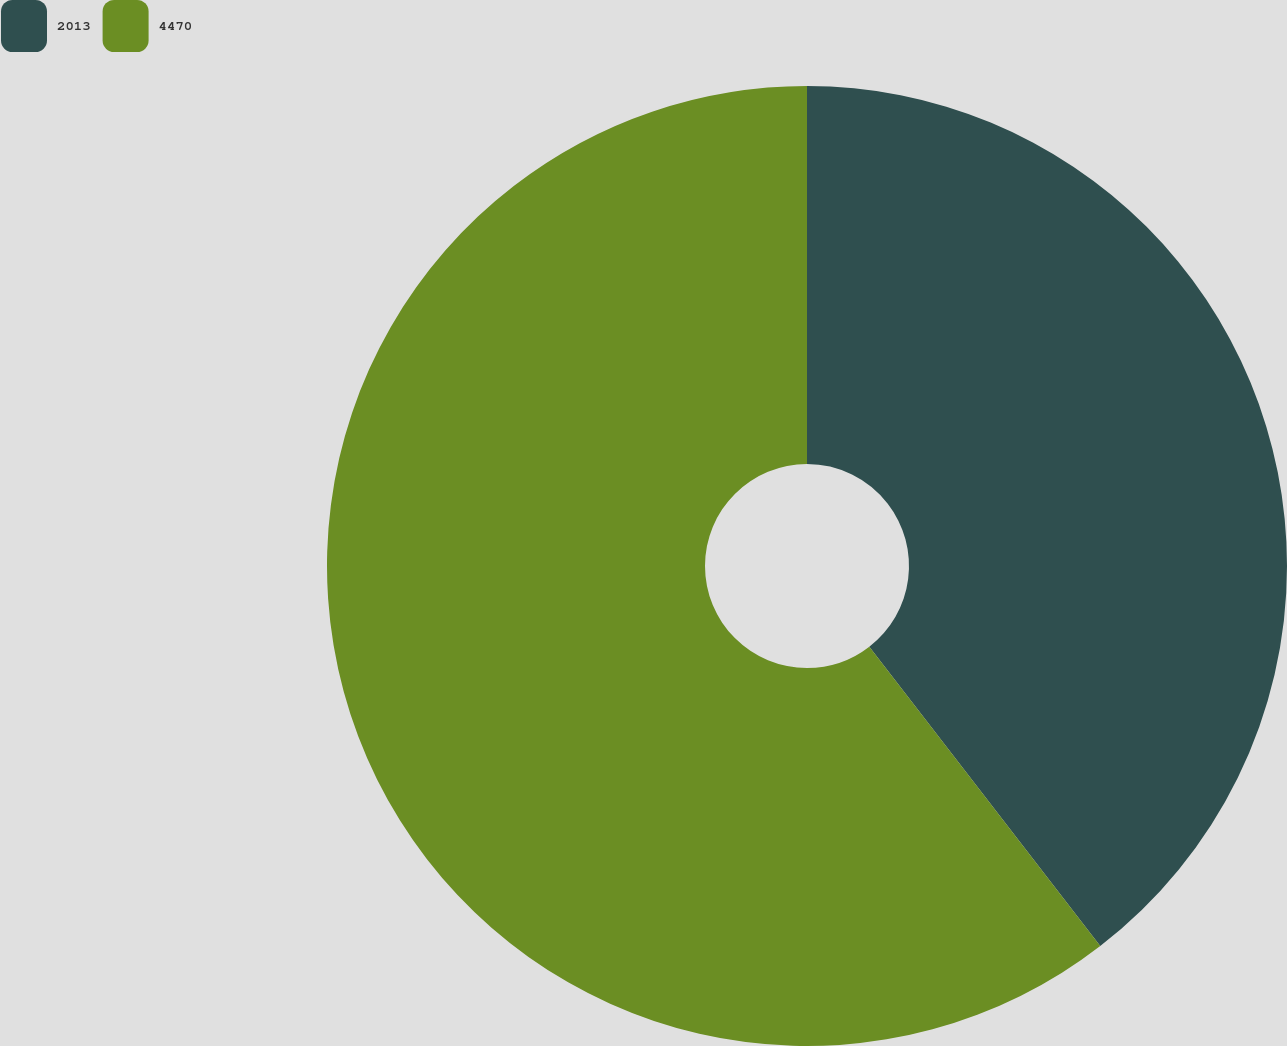Convert chart to OTSL. <chart><loc_0><loc_0><loc_500><loc_500><pie_chart><fcel>2013<fcel>4470<nl><fcel>39.54%<fcel>60.46%<nl></chart> 